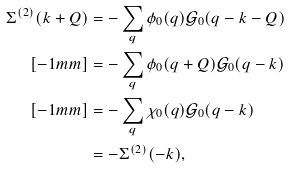<formula> <loc_0><loc_0><loc_500><loc_500>\Sigma ^ { ( 2 ) } ( k + Q ) & = - \sum _ { q } \phi _ { 0 } ( q ) \mathcal { G } _ { 0 } ( q - k - Q ) \\ [ - 1 m m ] & = - \sum _ { q } \phi _ { 0 } ( q + Q ) \mathcal { G } _ { 0 } ( q - k ) \\ [ - 1 m m ] & = - \sum _ { q } \chi _ { 0 } ( q ) \mathcal { G } _ { 0 } ( q - k ) \\ & = - \Sigma ^ { ( 2 ) } ( - k ) ,</formula> 